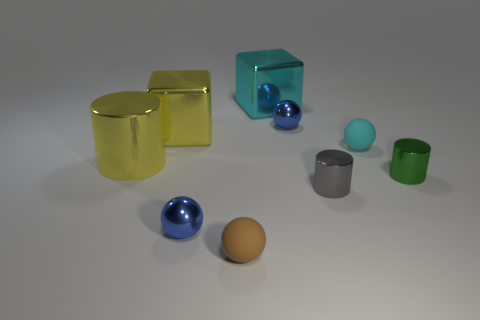What number of other things are the same material as the cyan cube?
Ensure brevity in your answer.  6. There is a large cube on the right side of the blue object on the left side of the large cyan object; what is it made of?
Keep it short and to the point. Metal. Are any green things visible?
Your response must be concise. Yes. There is a blue object that is right of the small metal object that is in front of the tiny gray thing; how big is it?
Give a very brief answer. Small. Are there more metal objects in front of the gray metallic cylinder than small cyan balls that are right of the tiny green metal cylinder?
Offer a terse response. Yes. How many balls are big yellow metal objects or blue objects?
Your answer should be very brief. 2. Is the shape of the tiny rubber object in front of the tiny gray shiny cylinder the same as  the tiny cyan matte object?
Ensure brevity in your answer.  Yes. What color is the large metal cylinder?
Offer a terse response. Yellow. What color is the other small thing that is the same shape as the tiny green thing?
Provide a short and direct response. Gray. How many other small matte things have the same shape as the tiny cyan matte object?
Provide a succinct answer. 1. 